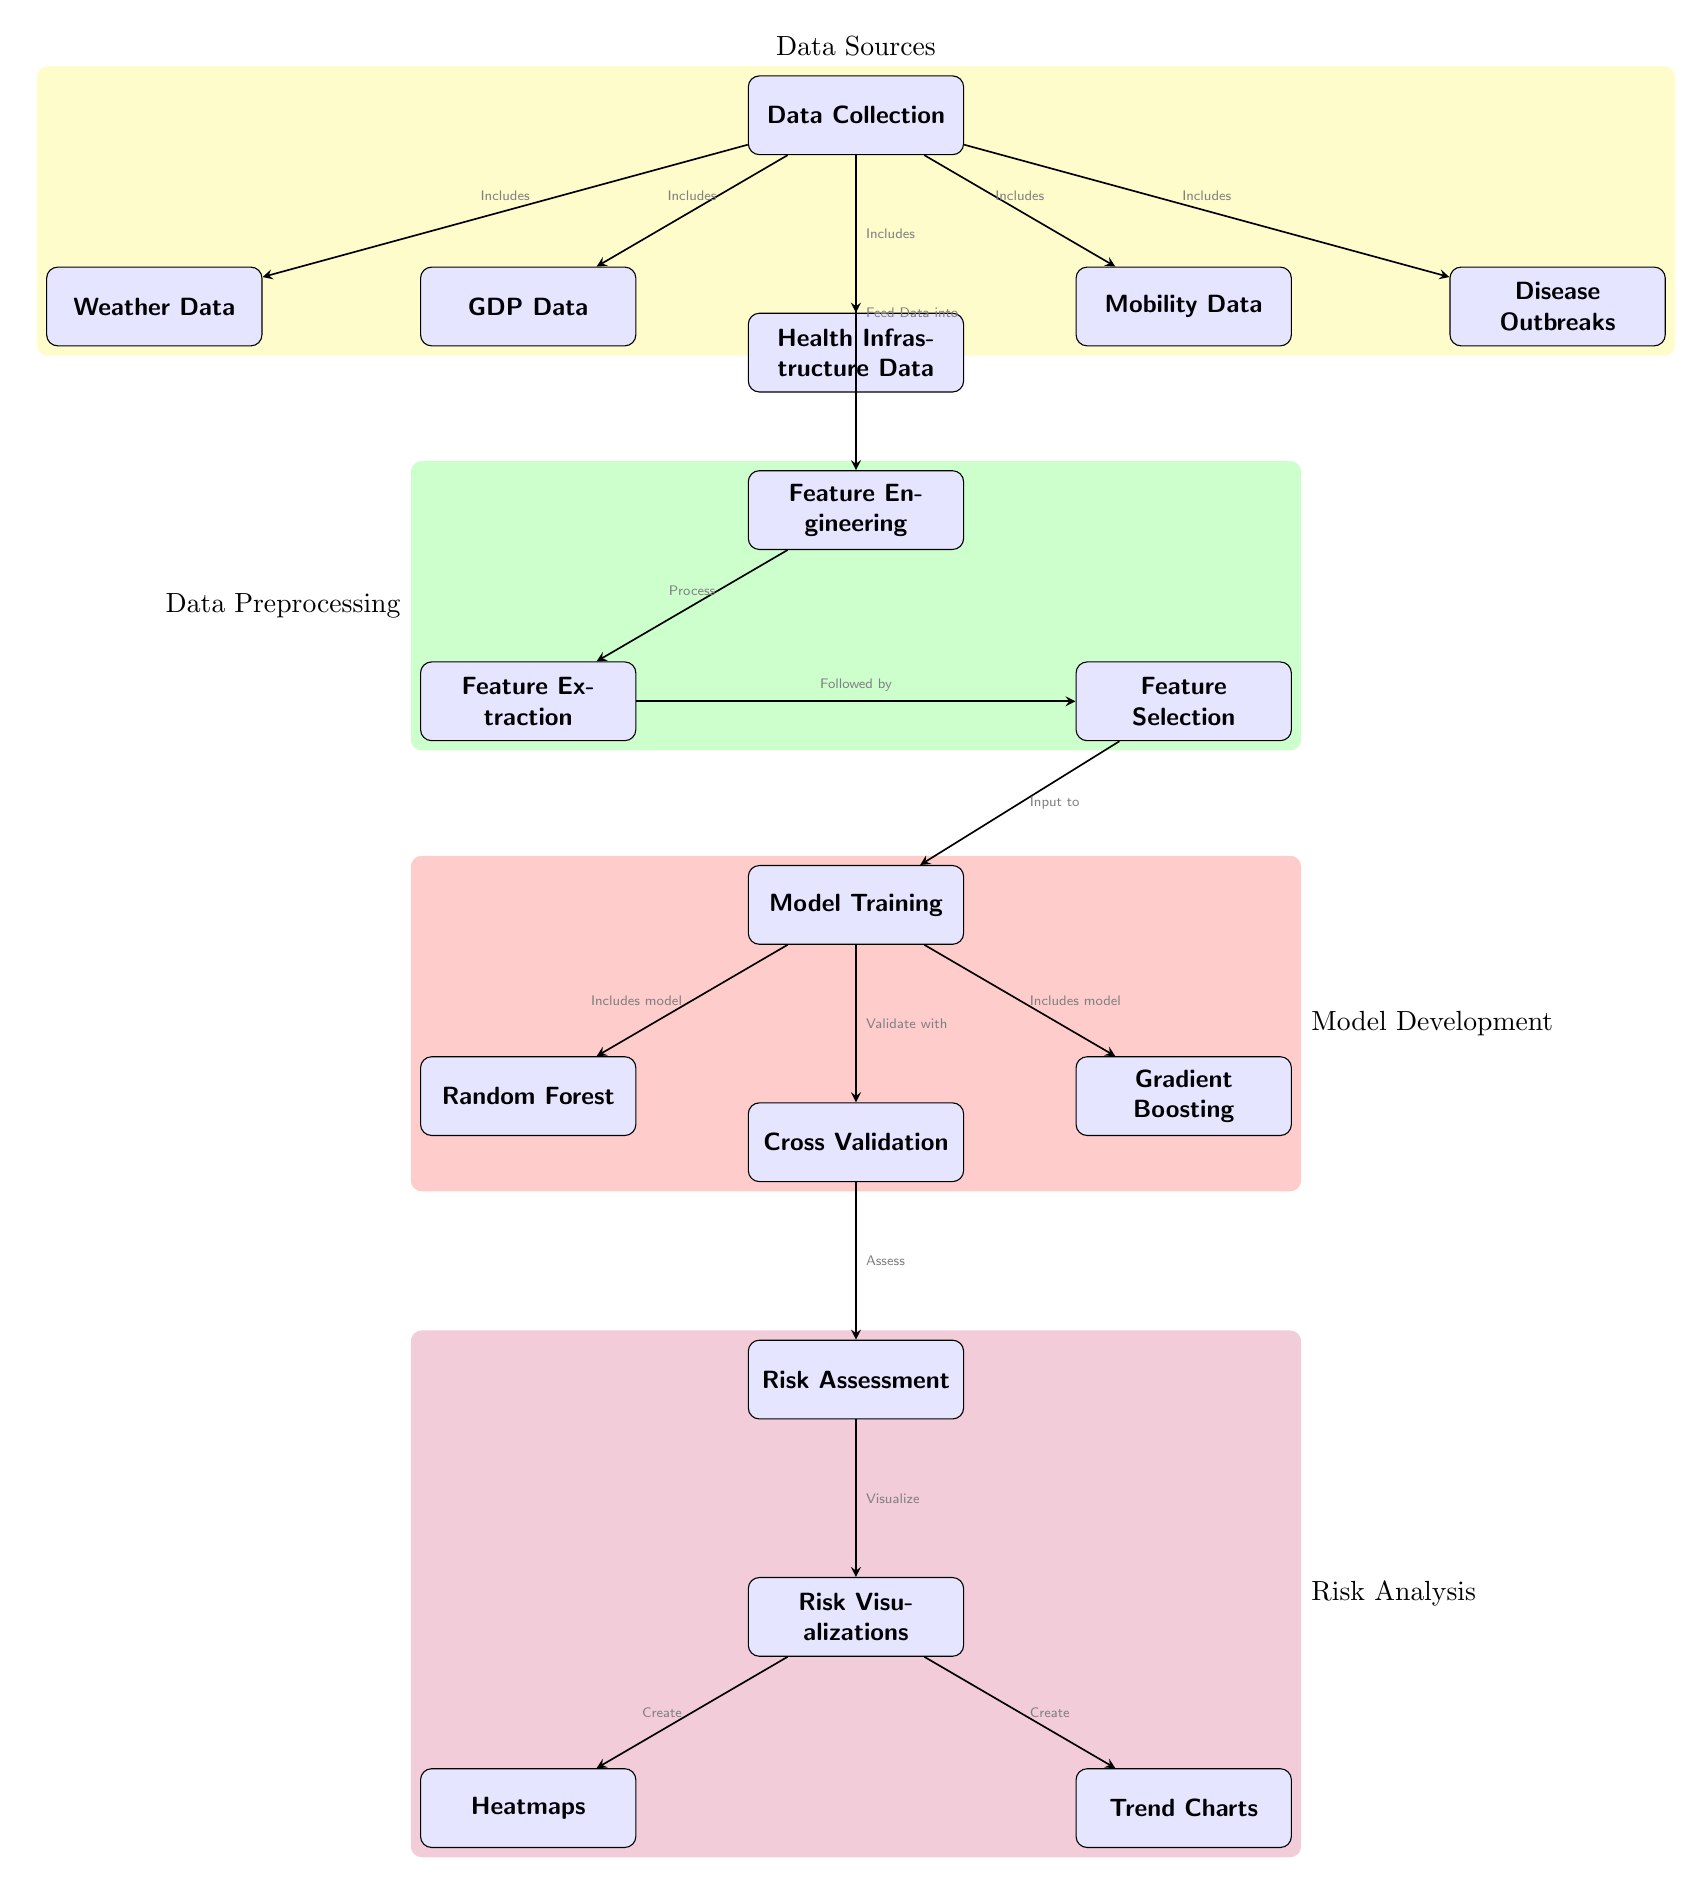What are the data types included in the Data Collection node? The Data Collection node connects to five specific nodes which represent the types of data included: GDP Data, Health Infrastructure Data, Mobility Data, Weather Data, and Disease Outbreaks.
Answer: GDP Data, Health Infrastructure Data, Mobility Data, Weather Data, Disease Outbreaks How many models are developed during Model Training? The Model Training node has edges connecting to two specific models: Random Forest and Gradient Boosting. Therefore, there are two models developed.
Answer: 2 What is the first step in the process represented in the diagram? The diagram starts with the Data Collection node, which indicates that the process begins with collecting data from various sources.
Answer: Data Collection Which step immediately follows Feature Engineering? After Feature Engineering, the next step indicated in the diagram is Model Training, suggesting that the engineered features are used to train models.
Answer: Model Training Which two types of visualizations are produced in Risk Visualizations? The Risk Visualizations node connects to two specific outputs labeled Heatmaps and Trend Charts, indicating that these are the types of visualizations created.
Answer: Heatmaps, Trend Charts What processes are included in Feature Engineering? The Feature Engineering node leads to two processes: Feature Extraction and Feature Selection, meaning both are integral to this stage of the diagram.
Answer: Feature Extraction, Feature Selection Which data type is most closely associated with the concept of mobility? The Mobility Data node is specifically related to the concept of mobility in the context of cross-border health risk prediction, making it the most relevant data type.
Answer: Mobility Data What role does Cross Validation play in the model development process? Cross Validation serves as an assessment step that follows Model Training, implying its role is to validate the performance of the developed models before moving to Risk Assessment.
Answer: Validate Describe the relationship between Risk Assessment and Risk Visualizations. The Risk Assessment node is linked to the Risk Visualizations node with an edge that signifies the process of visualizing the assessment results, indicating that visualizations are created based on the risk assessment outcomes.
Answer: Visualize 